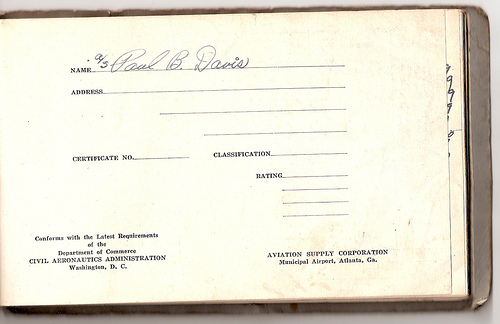<image>
Is there a word to the left of the line? Yes. From this viewpoint, the word is positioned to the left side relative to the line. 